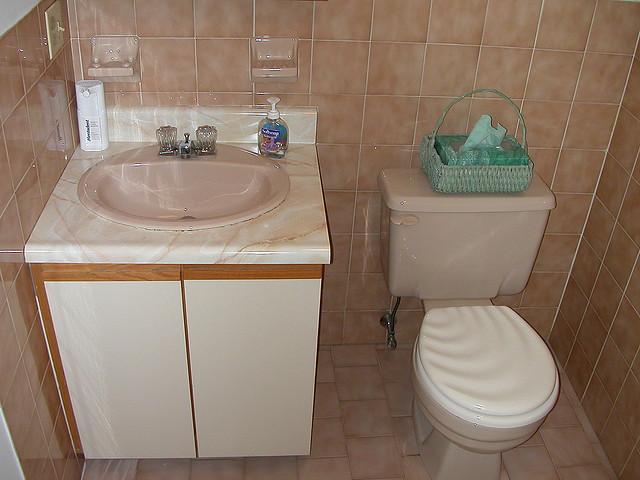What is on top of the toilet?
Keep it brief. Basket. Is this room messy?
Short answer required. No. Is there a sink in the photo?
Short answer required. Yes. 